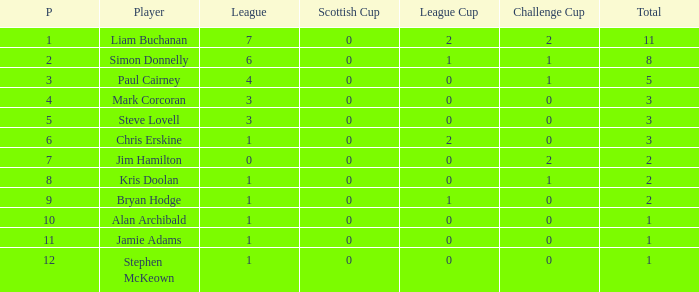Could you parse the entire table? {'header': ['P', 'Player', 'League', 'Scottish Cup', 'League Cup', 'Challenge Cup', 'Total'], 'rows': [['1', 'Liam Buchanan', '7', '0', '2', '2', '11'], ['2', 'Simon Donnelly', '6', '0', '1', '1', '8'], ['3', 'Paul Cairney', '4', '0', '0', '1', '5'], ['4', 'Mark Corcoran', '3', '0', '0', '0', '3'], ['5', 'Steve Lovell', '3', '0', '0', '0', '3'], ['6', 'Chris Erskine', '1', '0', '2', '0', '3'], ['7', 'Jim Hamilton', '0', '0', '0', '2', '2'], ['8', 'Kris Doolan', '1', '0', '0', '1', '2'], ['9', 'Bryan Hodge', '1', '0', '1', '0', '2'], ['10', 'Alan Archibald', '1', '0', '0', '0', '1'], ['11', 'Jamie Adams', '1', '0', '0', '0', '1'], ['12', 'Stephen McKeown', '1', '0', '0', '0', '1']]} What is bryan hodge's player number 1.0. 